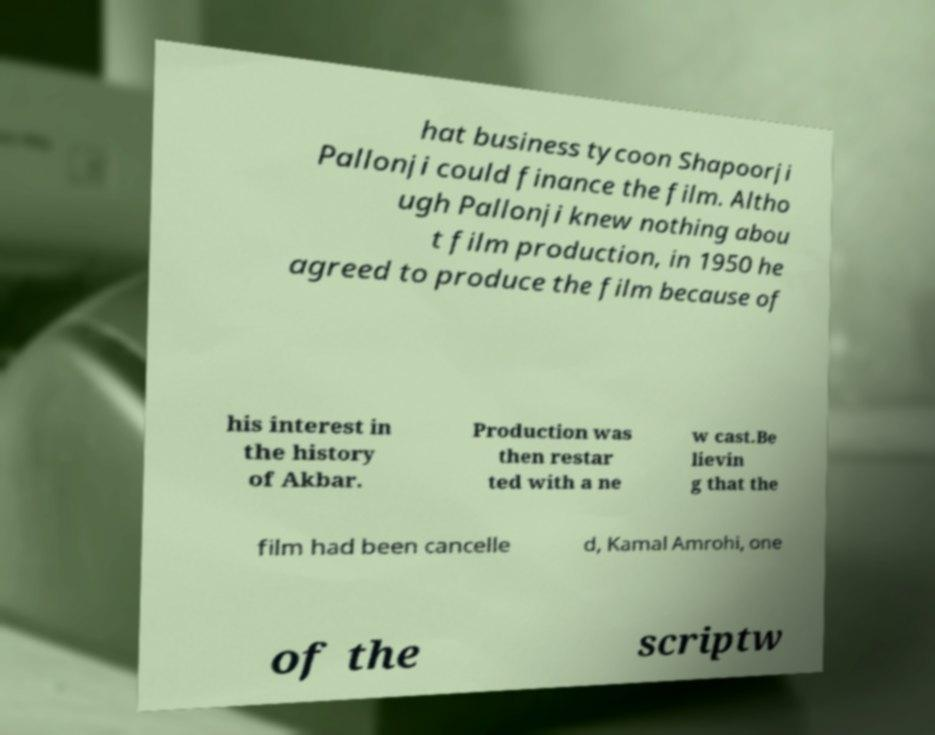There's text embedded in this image that I need extracted. Can you transcribe it verbatim? hat business tycoon Shapoorji Pallonji could finance the film. Altho ugh Pallonji knew nothing abou t film production, in 1950 he agreed to produce the film because of his interest in the history of Akbar. Production was then restar ted with a ne w cast.Be lievin g that the film had been cancelle d, Kamal Amrohi, one of the scriptw 